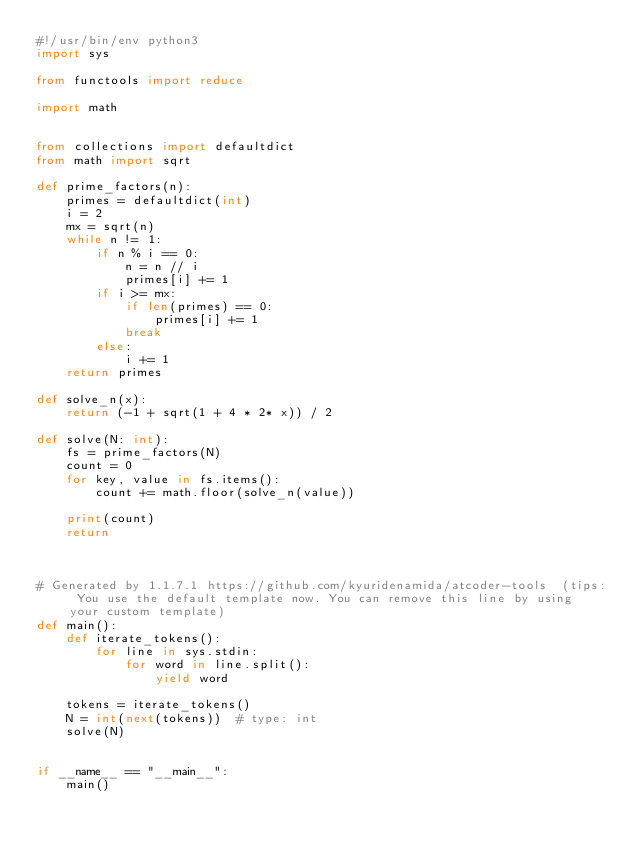Convert code to text. <code><loc_0><loc_0><loc_500><loc_500><_Python_>#!/usr/bin/env python3
import sys

from functools import reduce

import math


from collections import defaultdict
from math import sqrt

def prime_factors(n):
    primes = defaultdict(int)
    i = 2
    mx = sqrt(n)
    while n != 1:
        if n % i == 0:
            n = n // i
            primes[i] += 1
        if i >= mx:
            if len(primes) == 0:
                primes[i] += 1
            break
        else:
            i += 1
    return primes

def solve_n(x):
    return (-1 + sqrt(1 + 4 * 2* x)) / 2

def solve(N: int):
    fs = prime_factors(N)
    count = 0
    for key, value in fs.items():
        count += math.floor(solve_n(value))

    print(count)
    return



# Generated by 1.1.7.1 https://github.com/kyuridenamida/atcoder-tools  (tips: You use the default template now. You can remove this line by using your custom template)
def main():
    def iterate_tokens():
        for line in sys.stdin:
            for word in line.split():
                yield word

    tokens = iterate_tokens()
    N = int(next(tokens))  # type: int
    solve(N)


if __name__ == "__main__":
    main()
</code> 